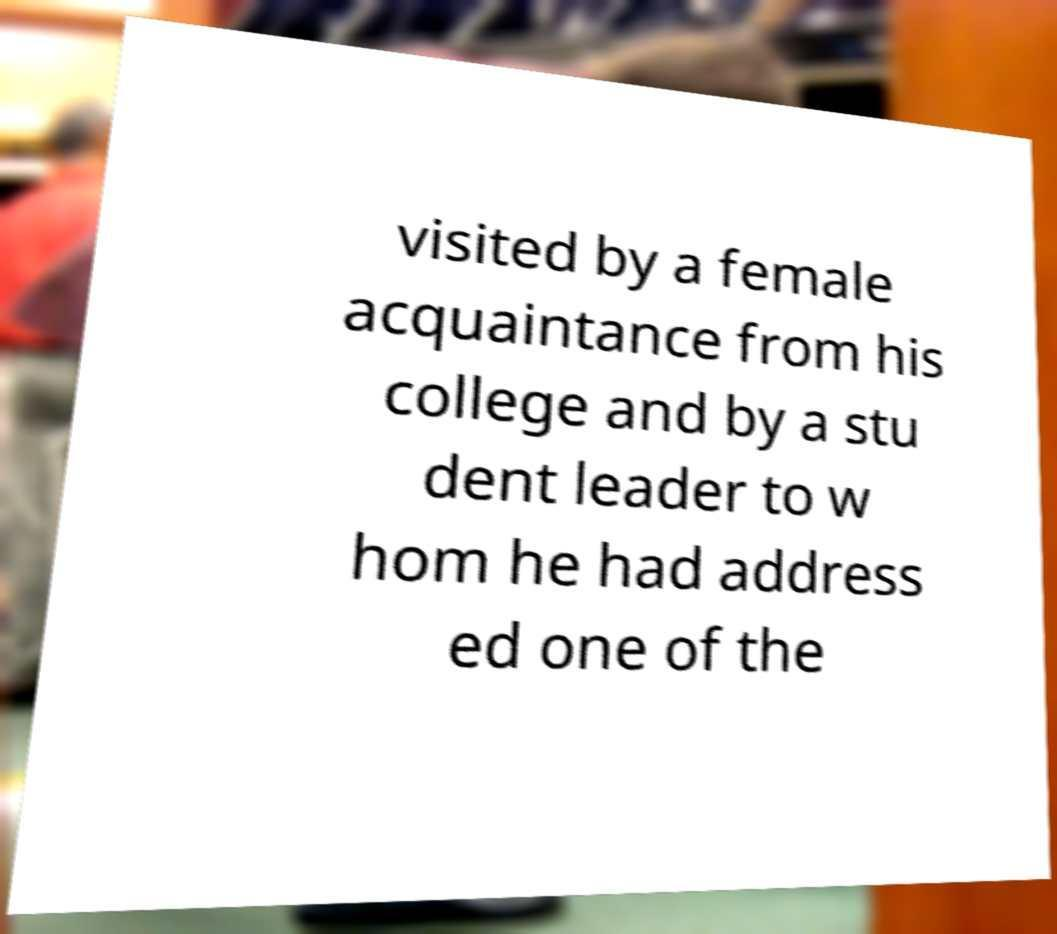Can you read and provide the text displayed in the image?This photo seems to have some interesting text. Can you extract and type it out for me? visited by a female acquaintance from his college and by a stu dent leader to w hom he had address ed one of the 